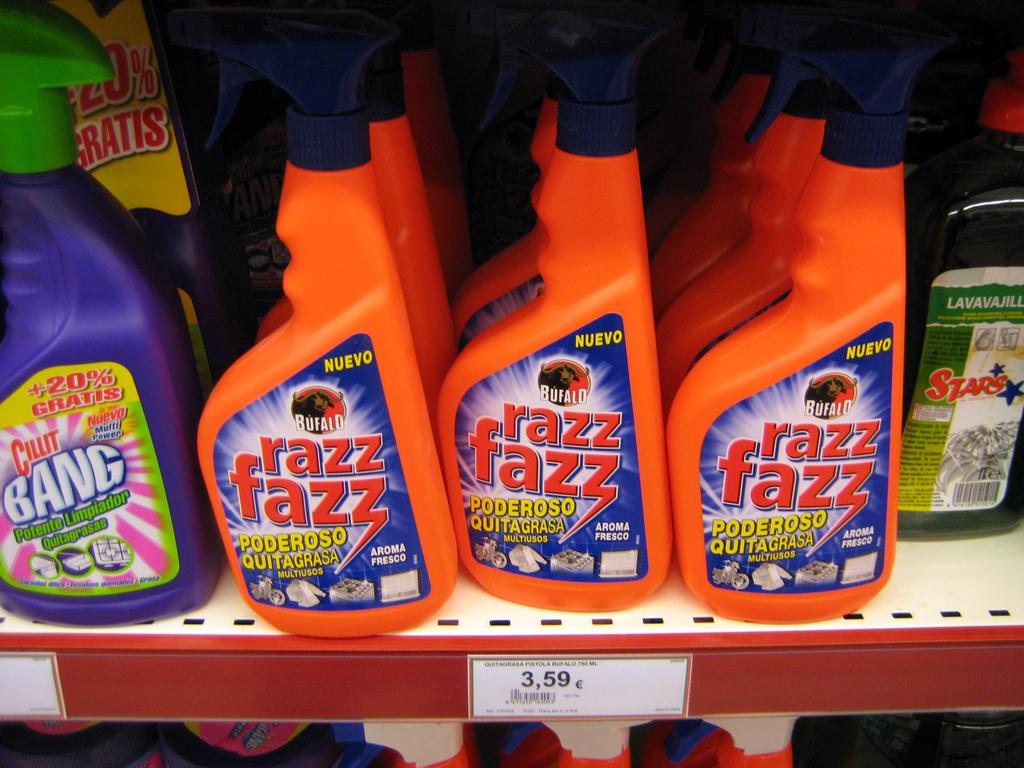What objects can be seen in the image? There are bottles in the image. Is there any information about the cost of the items in the image? Yes, there is a price tag in the image. What type of club is being used to perform arithmetic in the image? There is no club or arithmetic being performed in the image; it only features bottles and a price tag. 